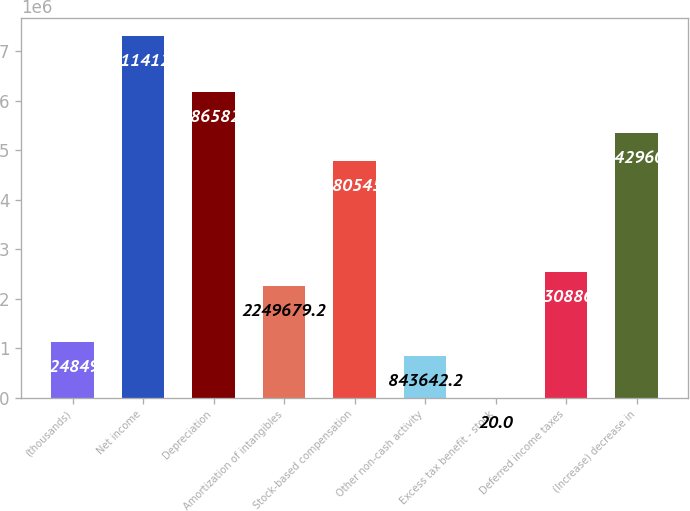<chart> <loc_0><loc_0><loc_500><loc_500><bar_chart><fcel>(thousands)<fcel>Net income<fcel>Depreciation<fcel>Amortization of intangibles<fcel>Stock-based compensation<fcel>Other non-cash activity<fcel>Excess tax benefit - stock<fcel>Deferred income taxes<fcel>(Increase) decrease in<nl><fcel>1.12485e+06<fcel>7.31141e+06<fcel>6.18658e+06<fcel>2.24968e+06<fcel>4.78055e+06<fcel>843642<fcel>20<fcel>2.53089e+06<fcel>5.34296e+06<nl></chart> 